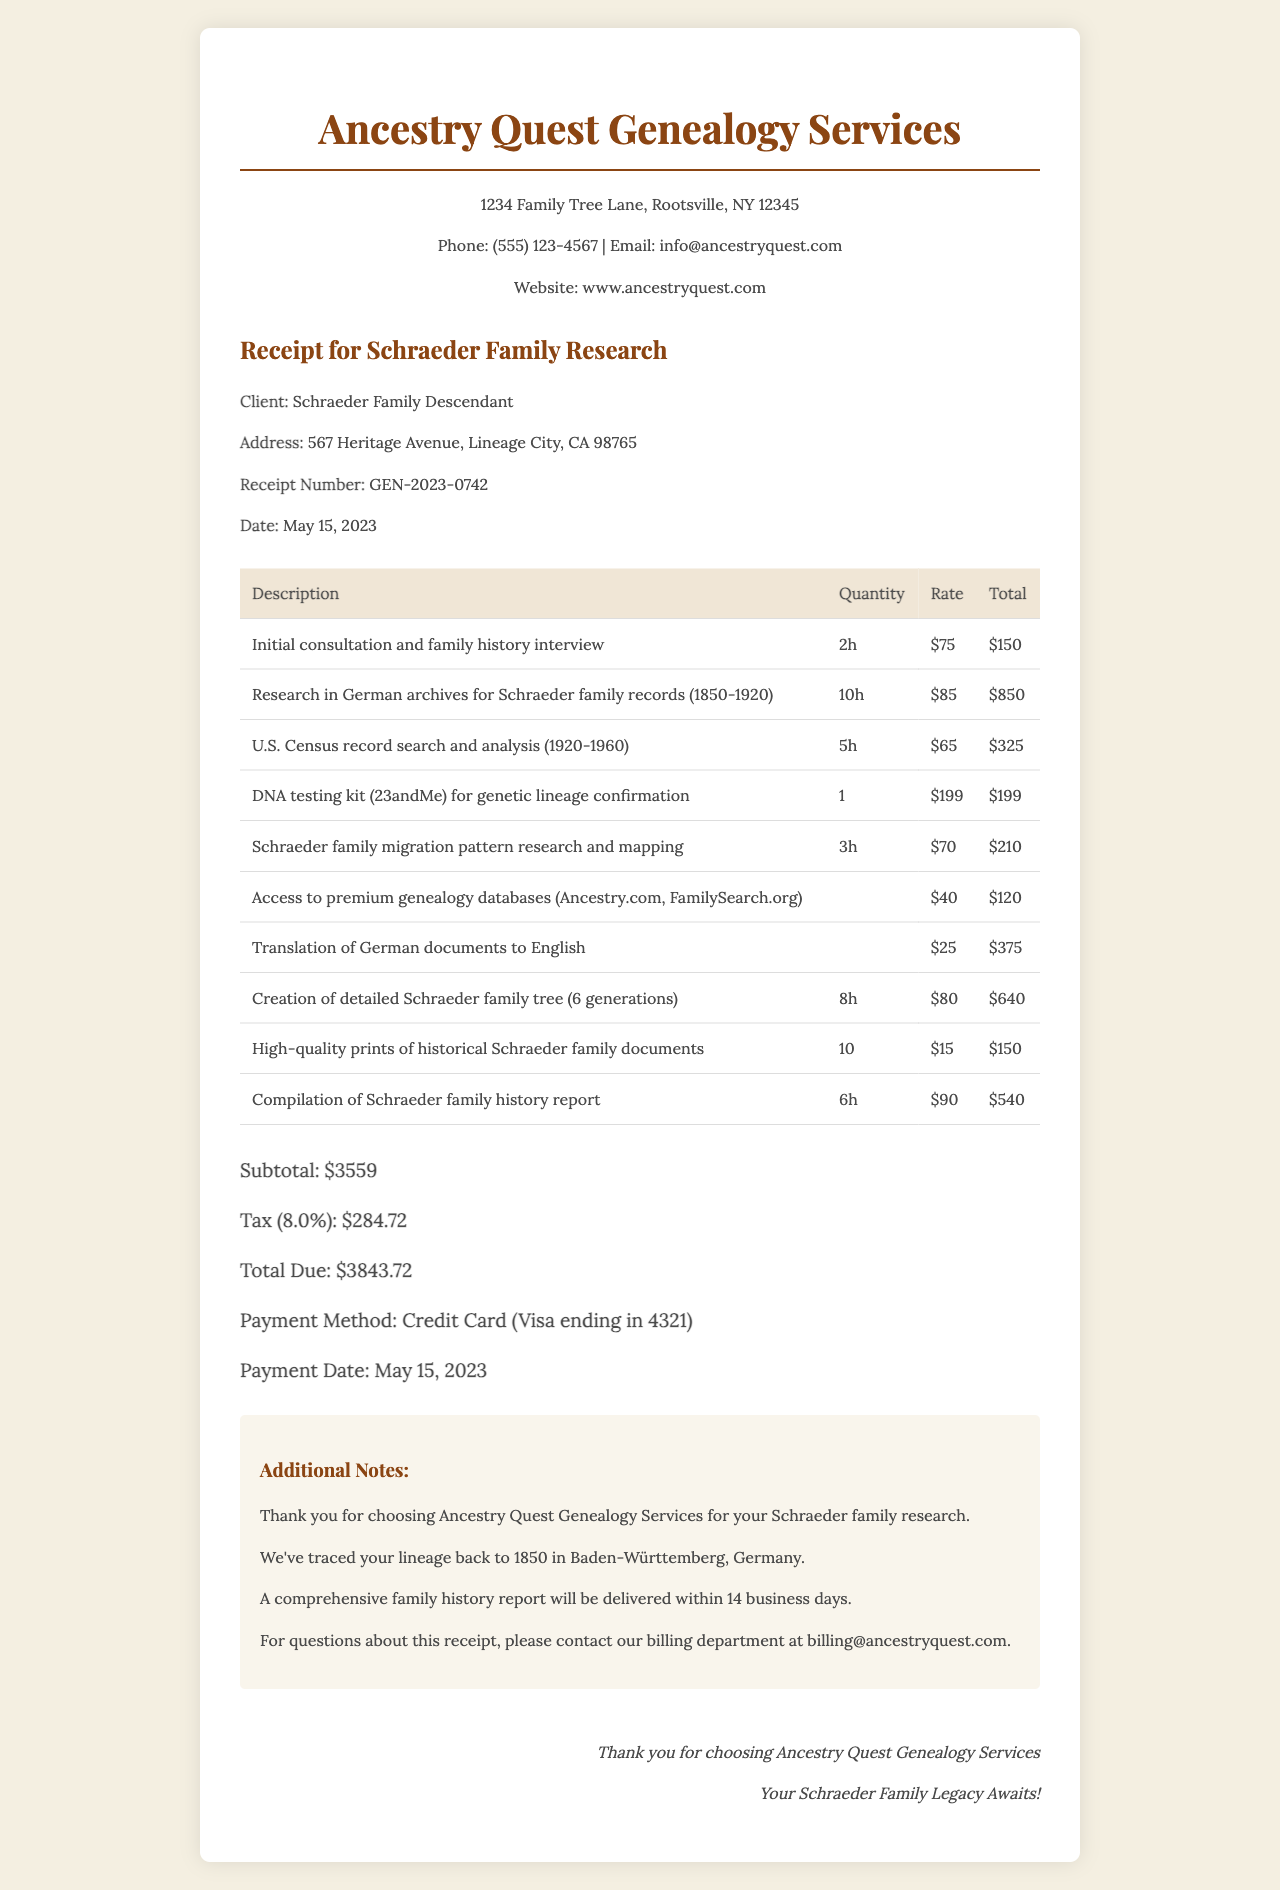what is the company name? The company name is listed at the top of the receipt.
Answer: Ancestry Quest Genealogy Services what is the total due? The total due is calculated at the bottom of the receipt.
Answer: $3843.72 how many pages were translated? The translation service lists the number of pages translated.
Answer: 15 what was the payment method? The payment method is specified in the payment information section.
Answer: Credit Card (Visa ending in 4321) how many hours were spent on U.S. Census record search? The hours for this specific service are detailed in the services section.
Answer: 5 how much was charged for DNA testing? The price for the DNA testing kit is provided within the services list.
Answer: $199 what is the item for access to genealogy databases? The description for this service reveals what it covers.
Answer: Access to premium genealogy databases (Ancestry.com, FamilySearch.org) how many months of genealogy database access were included? The duration for the access service is mentioned in the services section.
Answer: 3 months what is the receipt number? The receipt number can be found in the receipt details section.
Answer: GEN-2023-0742 